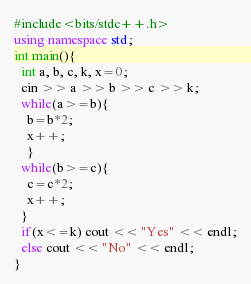<code> <loc_0><loc_0><loc_500><loc_500><_C++_>#include<bits/stdc++.h>
using namespace std;
int main(){
  int a, b, c, k, x=0;
  cin >> a >> b >> c >> k;
  while(a>=b){
    b=b*2;
    x++;
    }
  while(b>=c){
    c=c*2;
    x++;
  }
  if(x<=k) cout << "Yes" << endl;
  else cout << "No" << endl;
}
</code> 